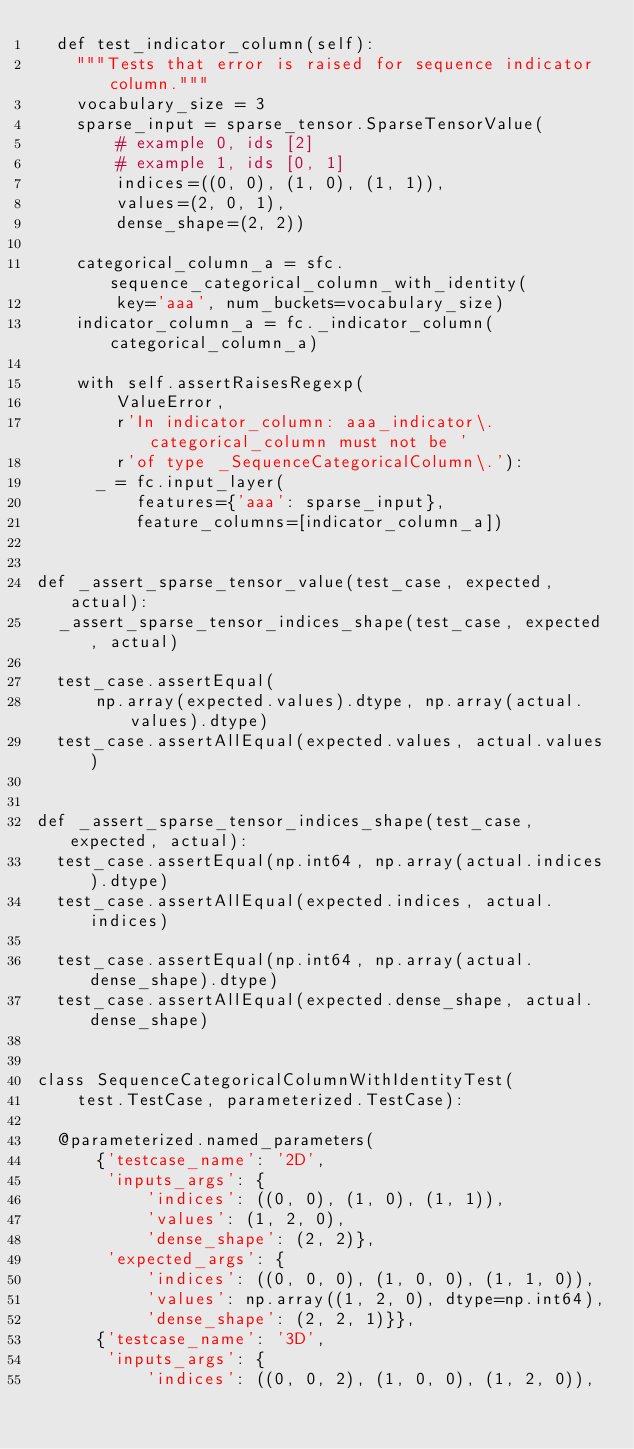<code> <loc_0><loc_0><loc_500><loc_500><_Python_>  def test_indicator_column(self):
    """Tests that error is raised for sequence indicator column."""
    vocabulary_size = 3
    sparse_input = sparse_tensor.SparseTensorValue(
        # example 0, ids [2]
        # example 1, ids [0, 1]
        indices=((0, 0), (1, 0), (1, 1)),
        values=(2, 0, 1),
        dense_shape=(2, 2))

    categorical_column_a = sfc.sequence_categorical_column_with_identity(
        key='aaa', num_buckets=vocabulary_size)
    indicator_column_a = fc._indicator_column(categorical_column_a)

    with self.assertRaisesRegexp(
        ValueError,
        r'In indicator_column: aaa_indicator\. categorical_column must not be '
        r'of type _SequenceCategoricalColumn\.'):
      _ = fc.input_layer(
          features={'aaa': sparse_input},
          feature_columns=[indicator_column_a])


def _assert_sparse_tensor_value(test_case, expected, actual):
  _assert_sparse_tensor_indices_shape(test_case, expected, actual)

  test_case.assertEqual(
      np.array(expected.values).dtype, np.array(actual.values).dtype)
  test_case.assertAllEqual(expected.values, actual.values)


def _assert_sparse_tensor_indices_shape(test_case, expected, actual):
  test_case.assertEqual(np.int64, np.array(actual.indices).dtype)
  test_case.assertAllEqual(expected.indices, actual.indices)

  test_case.assertEqual(np.int64, np.array(actual.dense_shape).dtype)
  test_case.assertAllEqual(expected.dense_shape, actual.dense_shape)


class SequenceCategoricalColumnWithIdentityTest(
    test.TestCase, parameterized.TestCase):

  @parameterized.named_parameters(
      {'testcase_name': '2D',
       'inputs_args': {
           'indices': ((0, 0), (1, 0), (1, 1)),
           'values': (1, 2, 0),
           'dense_shape': (2, 2)},
       'expected_args': {
           'indices': ((0, 0, 0), (1, 0, 0), (1, 1, 0)),
           'values': np.array((1, 2, 0), dtype=np.int64),
           'dense_shape': (2, 2, 1)}},
      {'testcase_name': '3D',
       'inputs_args': {
           'indices': ((0, 0, 2), (1, 0, 0), (1, 2, 0)),</code> 